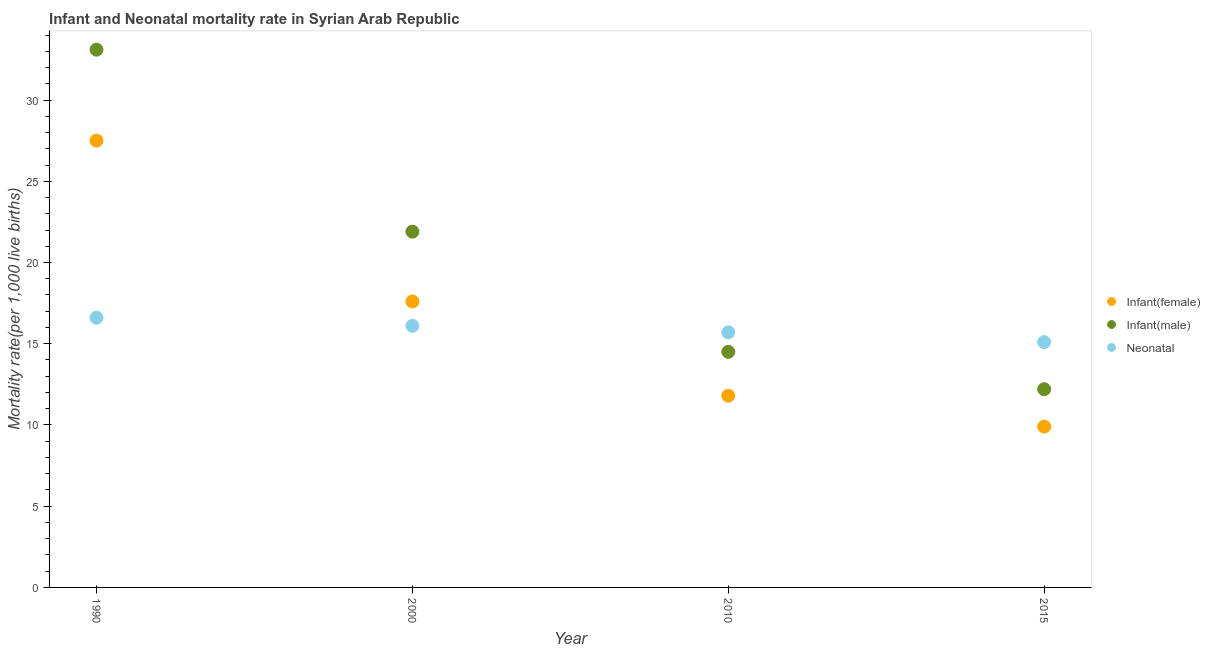Is the number of dotlines equal to the number of legend labels?
Your response must be concise. Yes. What is the neonatal mortality rate in 2015?
Your answer should be compact. 15.1. Across all years, what is the minimum infant mortality rate(male)?
Offer a terse response. 12.2. In which year was the infant mortality rate(male) maximum?
Ensure brevity in your answer.  1990. In which year was the neonatal mortality rate minimum?
Your response must be concise. 2015. What is the total neonatal mortality rate in the graph?
Your answer should be compact. 63.5. What is the difference between the infant mortality rate(female) in 1990 and that in 2000?
Provide a succinct answer. 9.9. What is the difference between the neonatal mortality rate in 2000 and the infant mortality rate(male) in 2015?
Make the answer very short. 3.9. What is the average infant mortality rate(male) per year?
Your answer should be very brief. 20.43. In the year 2000, what is the difference between the infant mortality rate(male) and neonatal mortality rate?
Your response must be concise. 5.8. In how many years, is the infant mortality rate(female) greater than 7?
Ensure brevity in your answer.  4. What is the ratio of the infant mortality rate(female) in 2000 to that in 2015?
Ensure brevity in your answer.  1.78. Is the infant mortality rate(male) in 1990 less than that in 2010?
Make the answer very short. No. What is the difference between the highest and the second highest infant mortality rate(female)?
Your response must be concise. 9.9. What is the difference between the highest and the lowest infant mortality rate(male)?
Offer a terse response. 20.9. In how many years, is the neonatal mortality rate greater than the average neonatal mortality rate taken over all years?
Ensure brevity in your answer.  2. Is it the case that in every year, the sum of the infant mortality rate(female) and infant mortality rate(male) is greater than the neonatal mortality rate?
Provide a short and direct response. Yes. Is the neonatal mortality rate strictly greater than the infant mortality rate(male) over the years?
Keep it short and to the point. No. Is the infant mortality rate(male) strictly less than the infant mortality rate(female) over the years?
Provide a short and direct response. No. How many dotlines are there?
Your response must be concise. 3. How many years are there in the graph?
Your answer should be very brief. 4. What is the difference between two consecutive major ticks on the Y-axis?
Make the answer very short. 5. Does the graph contain any zero values?
Make the answer very short. No. Does the graph contain grids?
Give a very brief answer. No. Where does the legend appear in the graph?
Your response must be concise. Center right. How are the legend labels stacked?
Ensure brevity in your answer.  Vertical. What is the title of the graph?
Offer a very short reply. Infant and Neonatal mortality rate in Syrian Arab Republic. What is the label or title of the X-axis?
Your response must be concise. Year. What is the label or title of the Y-axis?
Your response must be concise. Mortality rate(per 1,0 live births). What is the Mortality rate(per 1,000 live births) in Infant(male) in 1990?
Make the answer very short. 33.1. What is the Mortality rate(per 1,000 live births) in Infant(male) in 2000?
Give a very brief answer. 21.9. What is the Mortality rate(per 1,000 live births) in Neonatal  in 2010?
Make the answer very short. 15.7. What is the Mortality rate(per 1,000 live births) of Infant(female) in 2015?
Provide a succinct answer. 9.9. Across all years, what is the maximum Mortality rate(per 1,000 live births) of Infant(female)?
Make the answer very short. 27.5. Across all years, what is the maximum Mortality rate(per 1,000 live births) of Infant(male)?
Offer a terse response. 33.1. Across all years, what is the maximum Mortality rate(per 1,000 live births) in Neonatal ?
Offer a very short reply. 16.6. Across all years, what is the minimum Mortality rate(per 1,000 live births) of Infant(female)?
Give a very brief answer. 9.9. Across all years, what is the minimum Mortality rate(per 1,000 live births) of Infant(male)?
Your answer should be very brief. 12.2. What is the total Mortality rate(per 1,000 live births) in Infant(female) in the graph?
Your answer should be compact. 66.8. What is the total Mortality rate(per 1,000 live births) of Infant(male) in the graph?
Ensure brevity in your answer.  81.7. What is the total Mortality rate(per 1,000 live births) in Neonatal  in the graph?
Ensure brevity in your answer.  63.5. What is the difference between the Mortality rate(per 1,000 live births) of Infant(female) in 1990 and that in 2000?
Your response must be concise. 9.9. What is the difference between the Mortality rate(per 1,000 live births) in Neonatal  in 1990 and that in 2000?
Provide a short and direct response. 0.5. What is the difference between the Mortality rate(per 1,000 live births) of Infant(female) in 1990 and that in 2010?
Provide a succinct answer. 15.7. What is the difference between the Mortality rate(per 1,000 live births) in Infant(male) in 1990 and that in 2010?
Your answer should be very brief. 18.6. What is the difference between the Mortality rate(per 1,000 live births) in Infant(female) in 1990 and that in 2015?
Your response must be concise. 17.6. What is the difference between the Mortality rate(per 1,000 live births) of Infant(male) in 1990 and that in 2015?
Offer a very short reply. 20.9. What is the difference between the Mortality rate(per 1,000 live births) of Infant(male) in 2000 and that in 2010?
Make the answer very short. 7.4. What is the difference between the Mortality rate(per 1,000 live births) of Infant(female) in 2000 and that in 2015?
Your answer should be very brief. 7.7. What is the difference between the Mortality rate(per 1,000 live births) in Infant(male) in 2000 and that in 2015?
Your answer should be very brief. 9.7. What is the difference between the Mortality rate(per 1,000 live births) in Neonatal  in 2000 and that in 2015?
Offer a terse response. 1. What is the difference between the Mortality rate(per 1,000 live births) in Infant(female) in 2010 and that in 2015?
Your response must be concise. 1.9. What is the difference between the Mortality rate(per 1,000 live births) in Infant(female) in 1990 and the Mortality rate(per 1,000 live births) in Infant(male) in 2000?
Offer a terse response. 5.6. What is the difference between the Mortality rate(per 1,000 live births) in Infant(female) in 1990 and the Mortality rate(per 1,000 live births) in Neonatal  in 2010?
Make the answer very short. 11.8. What is the difference between the Mortality rate(per 1,000 live births) in Infant(male) in 1990 and the Mortality rate(per 1,000 live births) in Neonatal  in 2010?
Provide a short and direct response. 17.4. What is the difference between the Mortality rate(per 1,000 live births) in Infant(female) in 1990 and the Mortality rate(per 1,000 live births) in Infant(male) in 2015?
Ensure brevity in your answer.  15.3. What is the difference between the Mortality rate(per 1,000 live births) of Infant(female) in 1990 and the Mortality rate(per 1,000 live births) of Neonatal  in 2015?
Give a very brief answer. 12.4. What is the difference between the Mortality rate(per 1,000 live births) of Infant(female) in 2000 and the Mortality rate(per 1,000 live births) of Neonatal  in 2010?
Your answer should be very brief. 1.9. What is the difference between the Mortality rate(per 1,000 live births) in Infant(male) in 2000 and the Mortality rate(per 1,000 live births) in Neonatal  in 2010?
Give a very brief answer. 6.2. What is the difference between the Mortality rate(per 1,000 live births) of Infant(female) in 2000 and the Mortality rate(per 1,000 live births) of Infant(male) in 2015?
Your answer should be very brief. 5.4. What is the difference between the Mortality rate(per 1,000 live births) in Infant(female) in 2000 and the Mortality rate(per 1,000 live births) in Neonatal  in 2015?
Give a very brief answer. 2.5. What is the difference between the Mortality rate(per 1,000 live births) in Infant(male) in 2000 and the Mortality rate(per 1,000 live births) in Neonatal  in 2015?
Your response must be concise. 6.8. What is the average Mortality rate(per 1,000 live births) in Infant(male) per year?
Make the answer very short. 20.43. What is the average Mortality rate(per 1,000 live births) in Neonatal  per year?
Provide a succinct answer. 15.88. In the year 1990, what is the difference between the Mortality rate(per 1,000 live births) in Infant(female) and Mortality rate(per 1,000 live births) in Neonatal ?
Keep it short and to the point. 10.9. In the year 1990, what is the difference between the Mortality rate(per 1,000 live births) in Infant(male) and Mortality rate(per 1,000 live births) in Neonatal ?
Your response must be concise. 16.5. In the year 2000, what is the difference between the Mortality rate(per 1,000 live births) of Infant(female) and Mortality rate(per 1,000 live births) of Infant(male)?
Provide a short and direct response. -4.3. In the year 2000, what is the difference between the Mortality rate(per 1,000 live births) in Infant(male) and Mortality rate(per 1,000 live births) in Neonatal ?
Your answer should be very brief. 5.8. In the year 2010, what is the difference between the Mortality rate(per 1,000 live births) in Infant(female) and Mortality rate(per 1,000 live births) in Neonatal ?
Keep it short and to the point. -3.9. In the year 2010, what is the difference between the Mortality rate(per 1,000 live births) of Infant(male) and Mortality rate(per 1,000 live births) of Neonatal ?
Give a very brief answer. -1.2. In the year 2015, what is the difference between the Mortality rate(per 1,000 live births) in Infant(female) and Mortality rate(per 1,000 live births) in Infant(male)?
Your answer should be very brief. -2.3. What is the ratio of the Mortality rate(per 1,000 live births) in Infant(female) in 1990 to that in 2000?
Your answer should be compact. 1.56. What is the ratio of the Mortality rate(per 1,000 live births) of Infant(male) in 1990 to that in 2000?
Keep it short and to the point. 1.51. What is the ratio of the Mortality rate(per 1,000 live births) in Neonatal  in 1990 to that in 2000?
Offer a very short reply. 1.03. What is the ratio of the Mortality rate(per 1,000 live births) of Infant(female) in 1990 to that in 2010?
Ensure brevity in your answer.  2.33. What is the ratio of the Mortality rate(per 1,000 live births) in Infant(male) in 1990 to that in 2010?
Your answer should be very brief. 2.28. What is the ratio of the Mortality rate(per 1,000 live births) in Neonatal  in 1990 to that in 2010?
Give a very brief answer. 1.06. What is the ratio of the Mortality rate(per 1,000 live births) of Infant(female) in 1990 to that in 2015?
Your response must be concise. 2.78. What is the ratio of the Mortality rate(per 1,000 live births) of Infant(male) in 1990 to that in 2015?
Offer a terse response. 2.71. What is the ratio of the Mortality rate(per 1,000 live births) of Neonatal  in 1990 to that in 2015?
Your answer should be compact. 1.1. What is the ratio of the Mortality rate(per 1,000 live births) of Infant(female) in 2000 to that in 2010?
Provide a short and direct response. 1.49. What is the ratio of the Mortality rate(per 1,000 live births) in Infant(male) in 2000 to that in 2010?
Provide a short and direct response. 1.51. What is the ratio of the Mortality rate(per 1,000 live births) of Neonatal  in 2000 to that in 2010?
Ensure brevity in your answer.  1.03. What is the ratio of the Mortality rate(per 1,000 live births) in Infant(female) in 2000 to that in 2015?
Ensure brevity in your answer.  1.78. What is the ratio of the Mortality rate(per 1,000 live births) in Infant(male) in 2000 to that in 2015?
Offer a very short reply. 1.8. What is the ratio of the Mortality rate(per 1,000 live births) in Neonatal  in 2000 to that in 2015?
Offer a terse response. 1.07. What is the ratio of the Mortality rate(per 1,000 live births) of Infant(female) in 2010 to that in 2015?
Give a very brief answer. 1.19. What is the ratio of the Mortality rate(per 1,000 live births) of Infant(male) in 2010 to that in 2015?
Keep it short and to the point. 1.19. What is the ratio of the Mortality rate(per 1,000 live births) of Neonatal  in 2010 to that in 2015?
Provide a succinct answer. 1.04. What is the difference between the highest and the second highest Mortality rate(per 1,000 live births) in Infant(female)?
Keep it short and to the point. 9.9. What is the difference between the highest and the second highest Mortality rate(per 1,000 live births) of Infant(male)?
Your answer should be compact. 11.2. What is the difference between the highest and the lowest Mortality rate(per 1,000 live births) of Infant(female)?
Ensure brevity in your answer.  17.6. What is the difference between the highest and the lowest Mortality rate(per 1,000 live births) in Infant(male)?
Offer a very short reply. 20.9. What is the difference between the highest and the lowest Mortality rate(per 1,000 live births) in Neonatal ?
Provide a succinct answer. 1.5. 